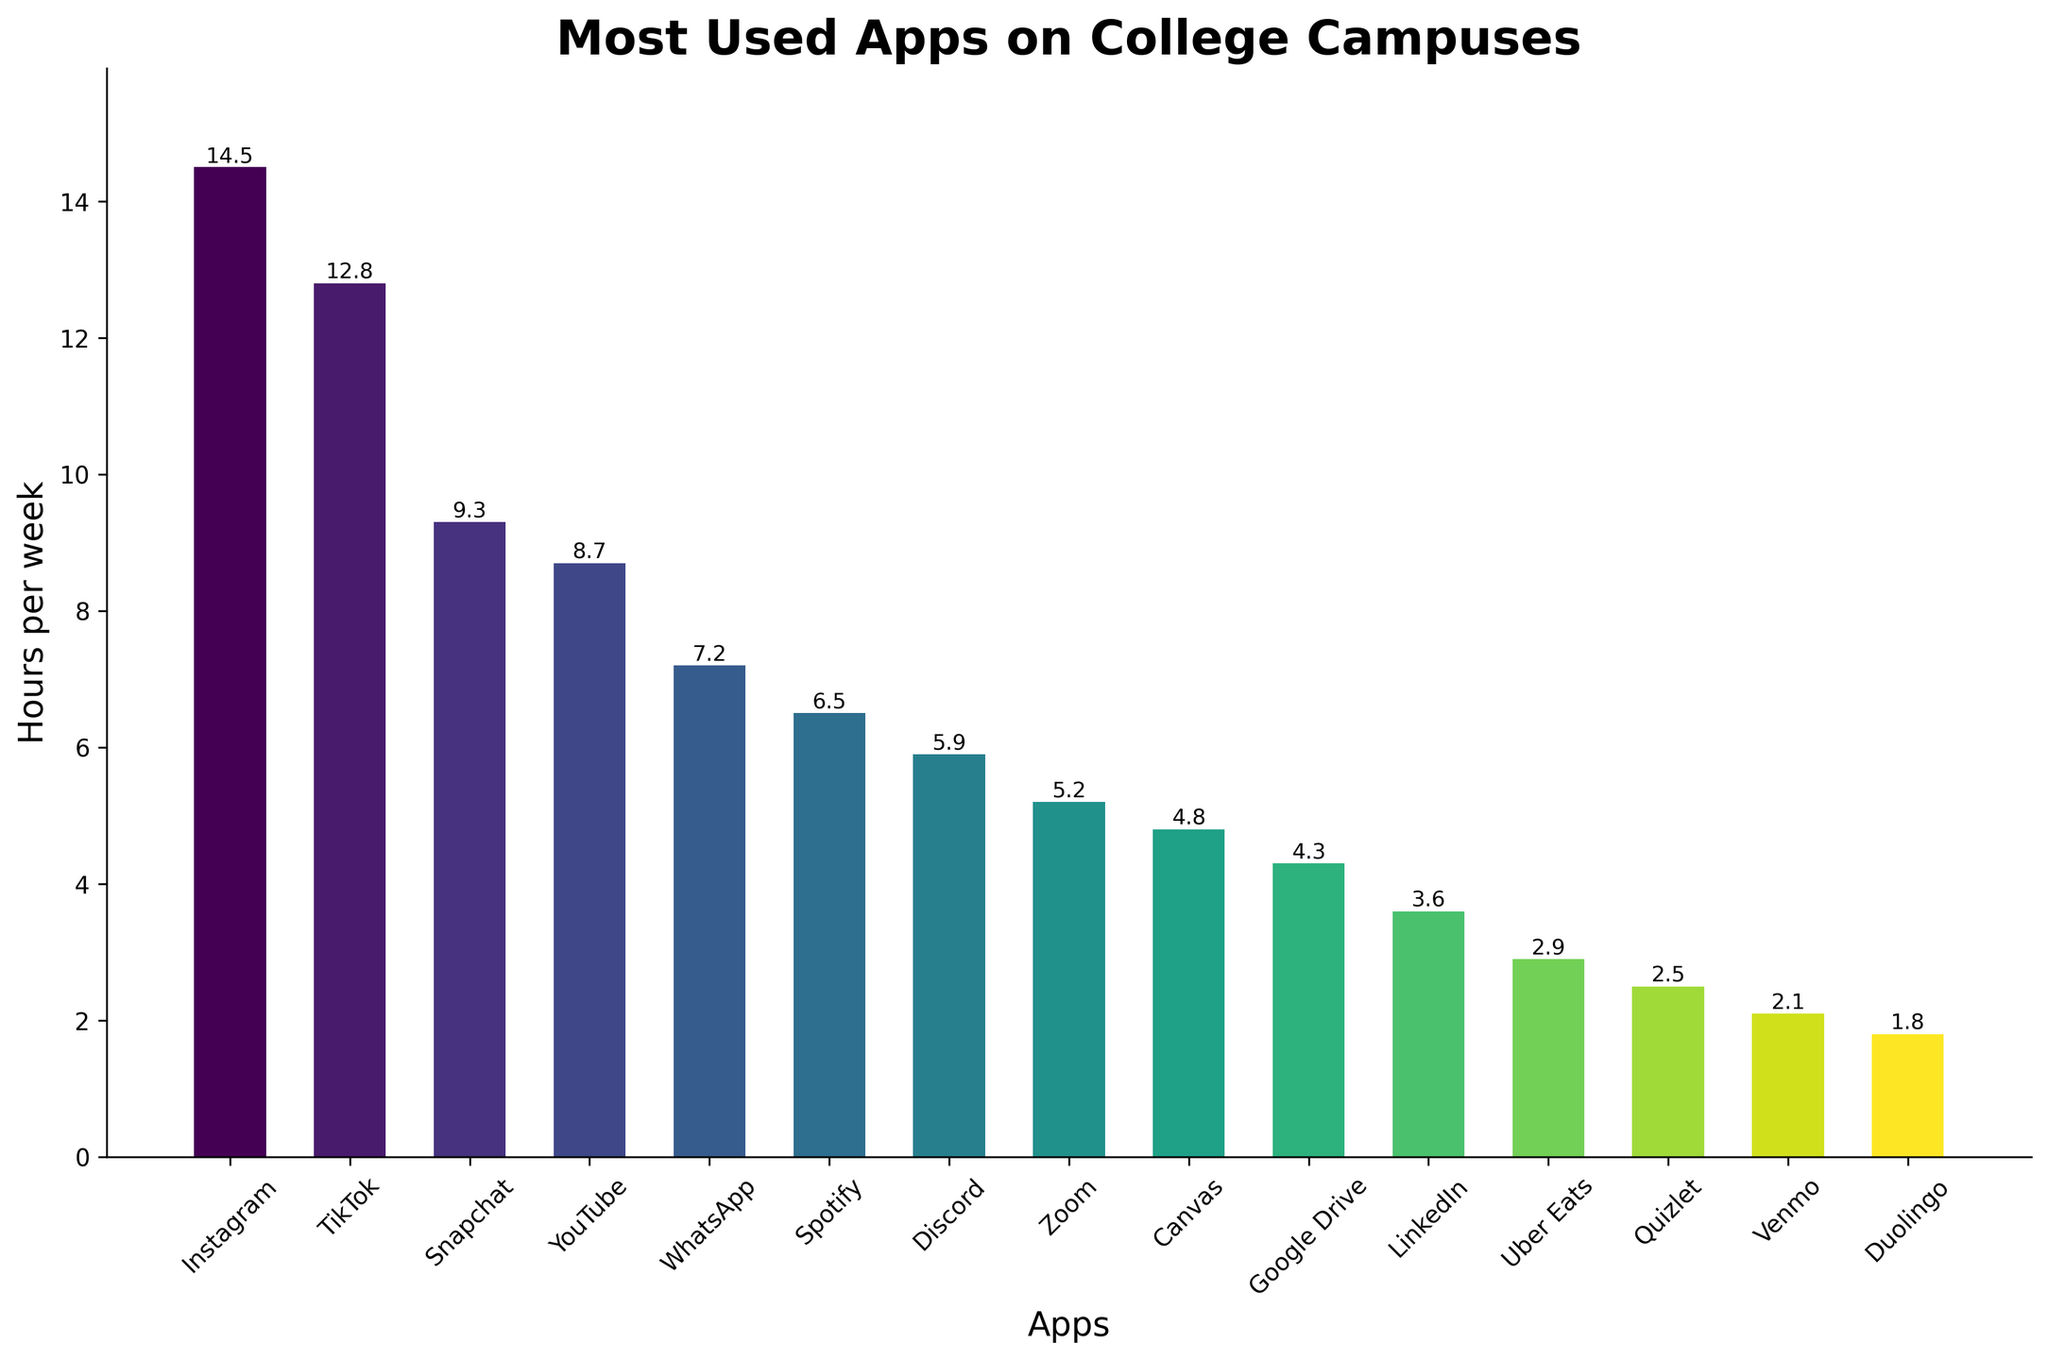Which app has the highest usage time per week? Look at the bar that reaches the highest point on the y-axis. The bar for Instagram is the tallest.
Answer: Instagram What is the difference in usage time between TikTok and WhatsApp? Find the heights of the bars for TikTok (12.8 hours) and WhatsApp (7.2 hours) and subtract the smaller value from the larger one. 12.8 - 7.2 = 5.6
Answer: 5.6 hours Which apps have a usage time of less than 5 hours per week? Identify the bars that do not extend above the 5-hour mark on the y-axis. These are Canvas, Google Drive, LinkedIn, Uber Eats, Quizlet, Venmo, and Duolingo.
Answer: Canvas, Google Drive, LinkedIn, Uber Eats, Quizlet, Venmo, Duolingo What is the total usage time of the three least used apps? Look at the smallest three bars which represent Venmo (2.1), Duolingo (1.8), and Quizlet (2.5). Sum these values: 2.1 + 1.8 + 2.5 = 6.4
Answer: 6.4 hours Which two apps have the closest usage times per week? Compare the heights of the bars to find two with very similar values. Discord (5.9) and Zoom (5.2) are the closest, with a difference of 0.7 hours.
Answer: Discord and Zoom What is the combined usage time of YouTube and Spotify per week? Add the heights of the bars for YouTube (8.7) and Spotify (6.5). 8.7 + 6.5 = 15.2
Answer: 15.2 hours How many apps have a usage time greater than 10 hours per week? Count the number of bars that extend above the 10-hour mark on the y-axis. Instagram and TikTok are the only ones that surpass this limit.
Answer: 2 Which app has the third highest usage time? Rank the bars in descending order of height. The third tallest bar is Snapchat at 9.3 hours.
Answer: Snapchat What is the average usage time for Canvas and Google Drive per week? Find the values for Canvas (4.8) and Google Drive (4.3), add them together and divide by 2. (4.8 + 4.3) / 2 = 4.55
Answer: 4.55 hours What is the difference between the most and least used apps? Determine the height of the tallest bar (Instagram at 14.5) and the shortest bar (Duolingo at 1.8). Subtract the smaller value from the larger one. 14.5 - 1.8 = 12.7
Answer: 12.7 hours 